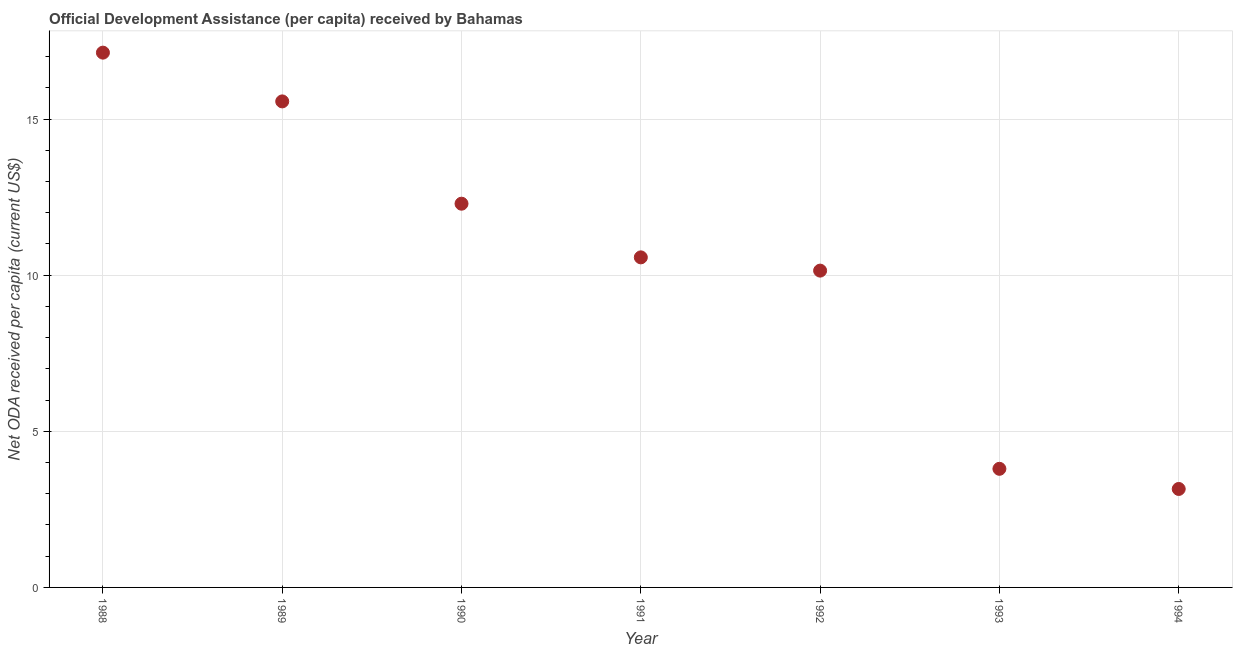What is the net oda received per capita in 1992?
Make the answer very short. 10.15. Across all years, what is the maximum net oda received per capita?
Provide a succinct answer. 17.13. Across all years, what is the minimum net oda received per capita?
Provide a short and direct response. 3.15. In which year was the net oda received per capita minimum?
Offer a very short reply. 1994. What is the sum of the net oda received per capita?
Your answer should be very brief. 72.65. What is the difference between the net oda received per capita in 1988 and 1990?
Provide a succinct answer. 4.84. What is the average net oda received per capita per year?
Provide a succinct answer. 10.38. What is the median net oda received per capita?
Offer a terse response. 10.57. What is the ratio of the net oda received per capita in 1989 to that in 1990?
Make the answer very short. 1.27. What is the difference between the highest and the second highest net oda received per capita?
Your answer should be compact. 1.56. Is the sum of the net oda received per capita in 1991 and 1994 greater than the maximum net oda received per capita across all years?
Your answer should be very brief. No. What is the difference between the highest and the lowest net oda received per capita?
Provide a short and direct response. 13.97. In how many years, is the net oda received per capita greater than the average net oda received per capita taken over all years?
Provide a short and direct response. 4. How many dotlines are there?
Your answer should be very brief. 1. How many years are there in the graph?
Your answer should be very brief. 7. Are the values on the major ticks of Y-axis written in scientific E-notation?
Your response must be concise. No. Does the graph contain any zero values?
Provide a succinct answer. No. What is the title of the graph?
Provide a short and direct response. Official Development Assistance (per capita) received by Bahamas. What is the label or title of the X-axis?
Offer a very short reply. Year. What is the label or title of the Y-axis?
Provide a short and direct response. Net ODA received per capita (current US$). What is the Net ODA received per capita (current US$) in 1988?
Provide a succinct answer. 17.13. What is the Net ODA received per capita (current US$) in 1989?
Your response must be concise. 15.56. What is the Net ODA received per capita (current US$) in 1990?
Your answer should be very brief. 12.29. What is the Net ODA received per capita (current US$) in 1991?
Make the answer very short. 10.57. What is the Net ODA received per capita (current US$) in 1992?
Give a very brief answer. 10.15. What is the Net ODA received per capita (current US$) in 1993?
Offer a terse response. 3.8. What is the Net ODA received per capita (current US$) in 1994?
Make the answer very short. 3.15. What is the difference between the Net ODA received per capita (current US$) in 1988 and 1989?
Offer a very short reply. 1.56. What is the difference between the Net ODA received per capita (current US$) in 1988 and 1990?
Your answer should be very brief. 4.84. What is the difference between the Net ODA received per capita (current US$) in 1988 and 1991?
Provide a short and direct response. 6.56. What is the difference between the Net ODA received per capita (current US$) in 1988 and 1992?
Ensure brevity in your answer.  6.98. What is the difference between the Net ODA received per capita (current US$) in 1988 and 1993?
Keep it short and to the point. 13.33. What is the difference between the Net ODA received per capita (current US$) in 1988 and 1994?
Your answer should be compact. 13.97. What is the difference between the Net ODA received per capita (current US$) in 1989 and 1990?
Offer a very short reply. 3.28. What is the difference between the Net ODA received per capita (current US$) in 1989 and 1991?
Keep it short and to the point. 4.99. What is the difference between the Net ODA received per capita (current US$) in 1989 and 1992?
Offer a very short reply. 5.42. What is the difference between the Net ODA received per capita (current US$) in 1989 and 1993?
Your answer should be compact. 11.77. What is the difference between the Net ODA received per capita (current US$) in 1989 and 1994?
Give a very brief answer. 12.41. What is the difference between the Net ODA received per capita (current US$) in 1990 and 1991?
Provide a succinct answer. 1.72. What is the difference between the Net ODA received per capita (current US$) in 1990 and 1992?
Offer a very short reply. 2.14. What is the difference between the Net ODA received per capita (current US$) in 1990 and 1993?
Your response must be concise. 8.49. What is the difference between the Net ODA received per capita (current US$) in 1990 and 1994?
Provide a succinct answer. 9.14. What is the difference between the Net ODA received per capita (current US$) in 1991 and 1992?
Offer a terse response. 0.42. What is the difference between the Net ODA received per capita (current US$) in 1991 and 1993?
Make the answer very short. 6.77. What is the difference between the Net ODA received per capita (current US$) in 1991 and 1994?
Provide a short and direct response. 7.42. What is the difference between the Net ODA received per capita (current US$) in 1992 and 1993?
Ensure brevity in your answer.  6.35. What is the difference between the Net ODA received per capita (current US$) in 1992 and 1994?
Your answer should be compact. 6.99. What is the difference between the Net ODA received per capita (current US$) in 1993 and 1994?
Provide a short and direct response. 0.65. What is the ratio of the Net ODA received per capita (current US$) in 1988 to that in 1989?
Keep it short and to the point. 1.1. What is the ratio of the Net ODA received per capita (current US$) in 1988 to that in 1990?
Your answer should be compact. 1.39. What is the ratio of the Net ODA received per capita (current US$) in 1988 to that in 1991?
Give a very brief answer. 1.62. What is the ratio of the Net ODA received per capita (current US$) in 1988 to that in 1992?
Ensure brevity in your answer.  1.69. What is the ratio of the Net ODA received per capita (current US$) in 1988 to that in 1993?
Your response must be concise. 4.51. What is the ratio of the Net ODA received per capita (current US$) in 1988 to that in 1994?
Keep it short and to the point. 5.43. What is the ratio of the Net ODA received per capita (current US$) in 1989 to that in 1990?
Your answer should be compact. 1.27. What is the ratio of the Net ODA received per capita (current US$) in 1989 to that in 1991?
Your answer should be compact. 1.47. What is the ratio of the Net ODA received per capita (current US$) in 1989 to that in 1992?
Offer a very short reply. 1.53. What is the ratio of the Net ODA received per capita (current US$) in 1989 to that in 1993?
Give a very brief answer. 4.1. What is the ratio of the Net ODA received per capita (current US$) in 1989 to that in 1994?
Your response must be concise. 4.94. What is the ratio of the Net ODA received per capita (current US$) in 1990 to that in 1991?
Your answer should be compact. 1.16. What is the ratio of the Net ODA received per capita (current US$) in 1990 to that in 1992?
Make the answer very short. 1.21. What is the ratio of the Net ODA received per capita (current US$) in 1990 to that in 1993?
Provide a short and direct response. 3.23. What is the ratio of the Net ODA received per capita (current US$) in 1990 to that in 1994?
Make the answer very short. 3.9. What is the ratio of the Net ODA received per capita (current US$) in 1991 to that in 1992?
Offer a terse response. 1.04. What is the ratio of the Net ODA received per capita (current US$) in 1991 to that in 1993?
Make the answer very short. 2.78. What is the ratio of the Net ODA received per capita (current US$) in 1991 to that in 1994?
Your response must be concise. 3.35. What is the ratio of the Net ODA received per capita (current US$) in 1992 to that in 1993?
Your response must be concise. 2.67. What is the ratio of the Net ODA received per capita (current US$) in 1992 to that in 1994?
Provide a short and direct response. 3.22. What is the ratio of the Net ODA received per capita (current US$) in 1993 to that in 1994?
Your answer should be compact. 1.21. 